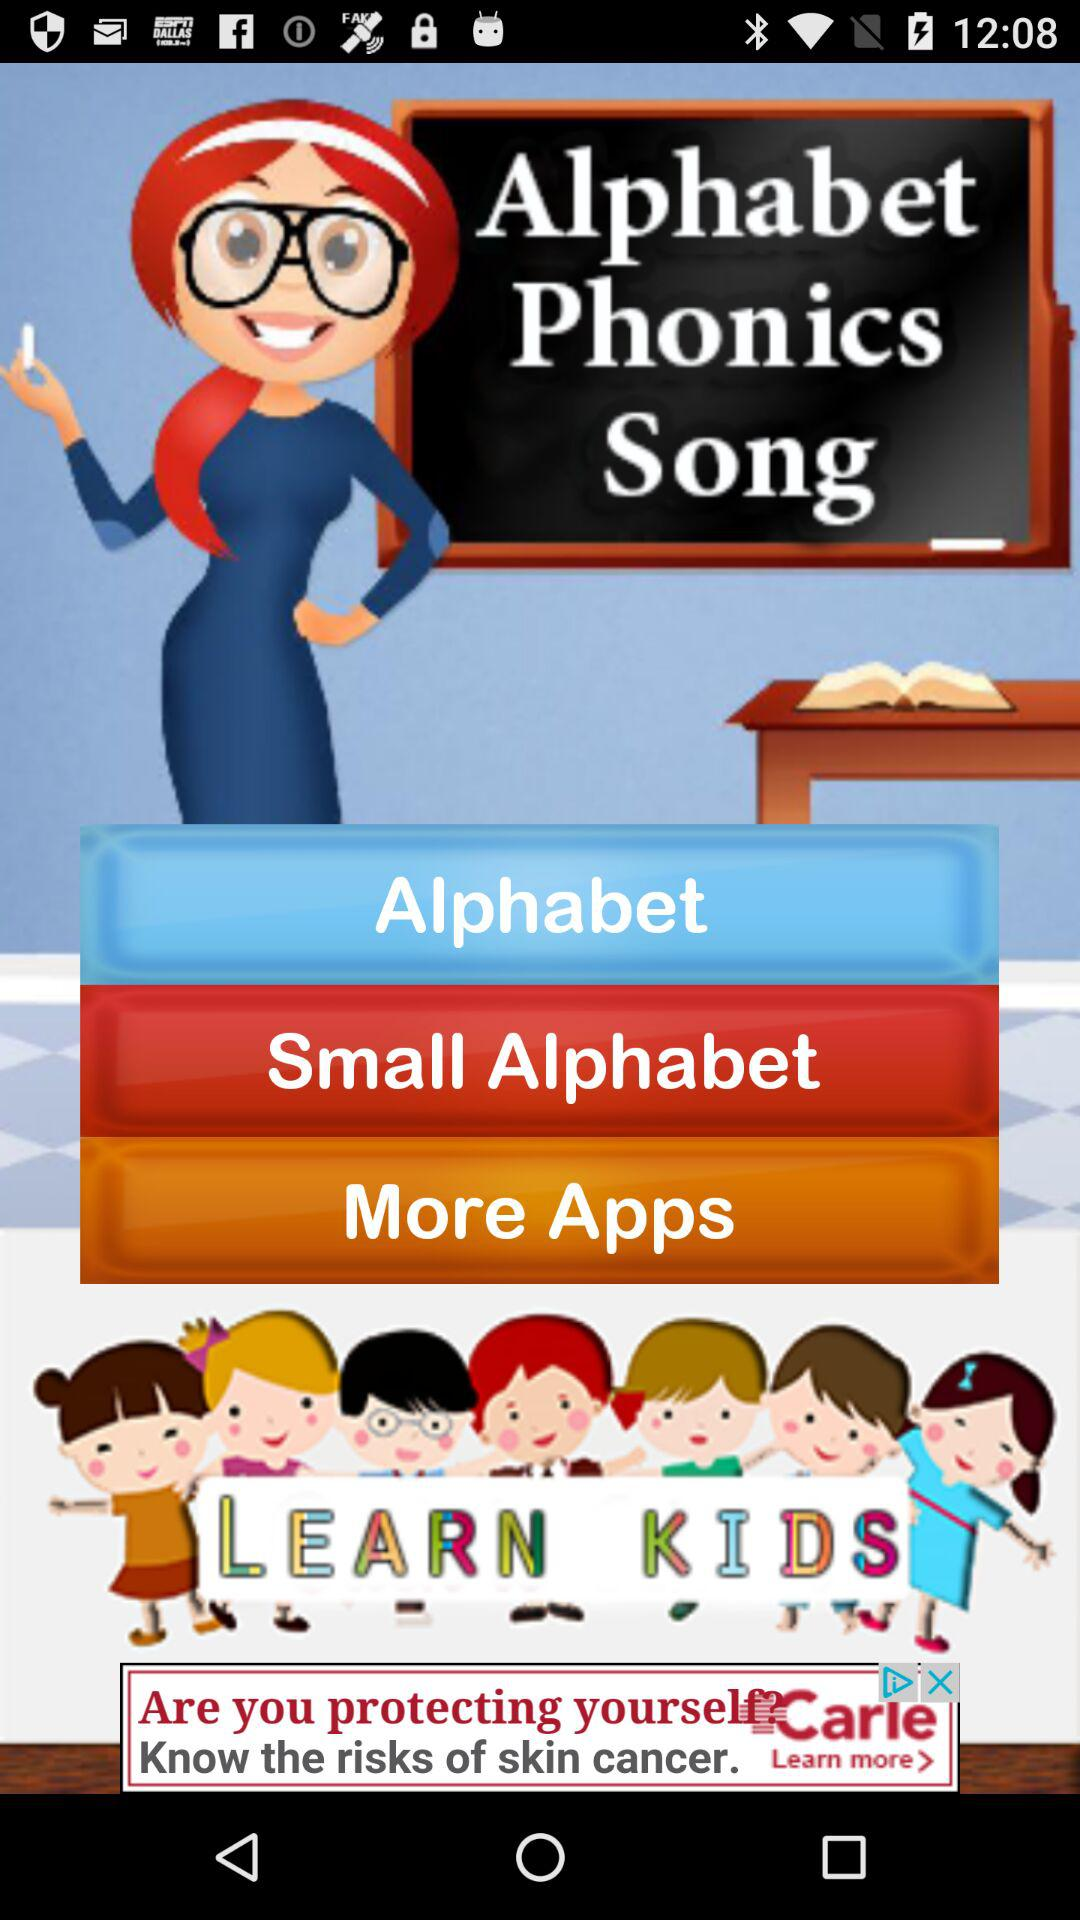What is the application name? The application name is "Alphabet Phonics Song". 